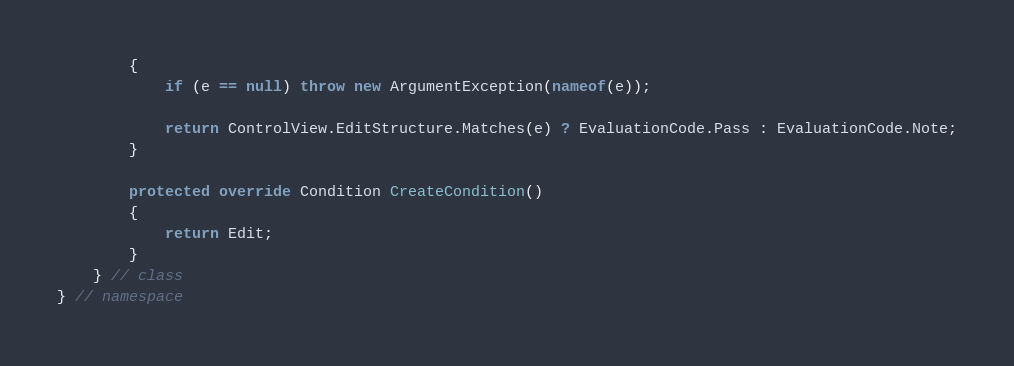Convert code to text. <code><loc_0><loc_0><loc_500><loc_500><_C#_>        {
            if (e == null) throw new ArgumentException(nameof(e));

            return ControlView.EditStructure.Matches(e) ? EvaluationCode.Pass : EvaluationCode.Note;
        }

        protected override Condition CreateCondition()
        {
            return Edit;
        }
    } // class
} // namespace
</code> 